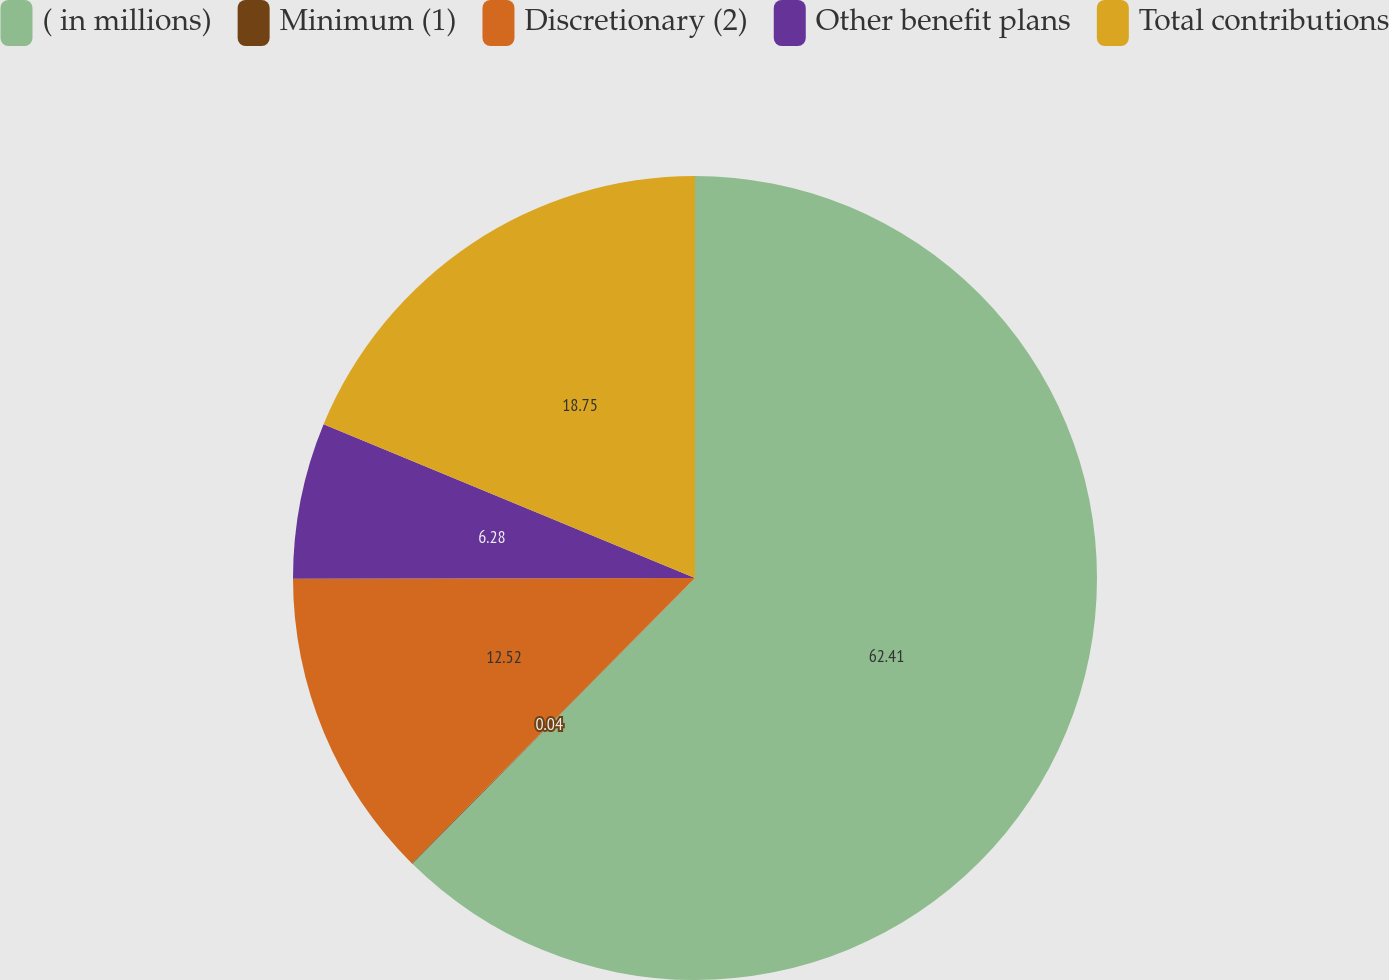<chart> <loc_0><loc_0><loc_500><loc_500><pie_chart><fcel>( in millions)<fcel>Minimum (1)<fcel>Discretionary (2)<fcel>Other benefit plans<fcel>Total contributions<nl><fcel>62.41%<fcel>0.04%<fcel>12.52%<fcel>6.28%<fcel>18.75%<nl></chart> 